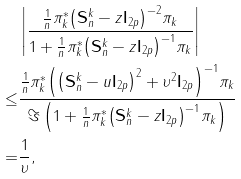Convert formula to latex. <formula><loc_0><loc_0><loc_500><loc_500>& \left | \frac { \frac { 1 } { n } { \pi _ { k } ^ { * } { { \left ( \mathbf S _ { n } ^ { k } - z { \mathbf I _ { 2 p } } \right ) } ^ { - 2 } } { \pi _ { k } } } } { { 1 + \frac { 1 } { n } \pi _ { k } ^ { * } { { \left ( \mathbf S _ { n } ^ { k } - z { \mathbf I _ { 2 p } } \right ) } ^ { - 1 } } { \pi _ { k } } } } \right | \\ \leq & \frac { \frac { 1 } { n } { \pi _ { k } ^ { * } { { \left ( { { \left ( \mathbf S _ { n } ^ { k } - u { \mathbf I _ { 2 p } } \right ) } ^ { 2 } } + { \upsilon ^ { 2 } } { \mathbf I _ { 2 p } } \right ) } ^ { - 1 } } { \pi _ { k } } } } { { \Im \left ( 1 + \frac { 1 } { n } \pi _ { k } ^ { * } { { \left ( \mathbf S _ { n } ^ { k } - z { \mathbf I _ { 2 p } } \right ) } ^ { - 1 } } { \pi _ { k } } \right ) } } \\ = & \frac { 1 } { \upsilon } ,</formula> 